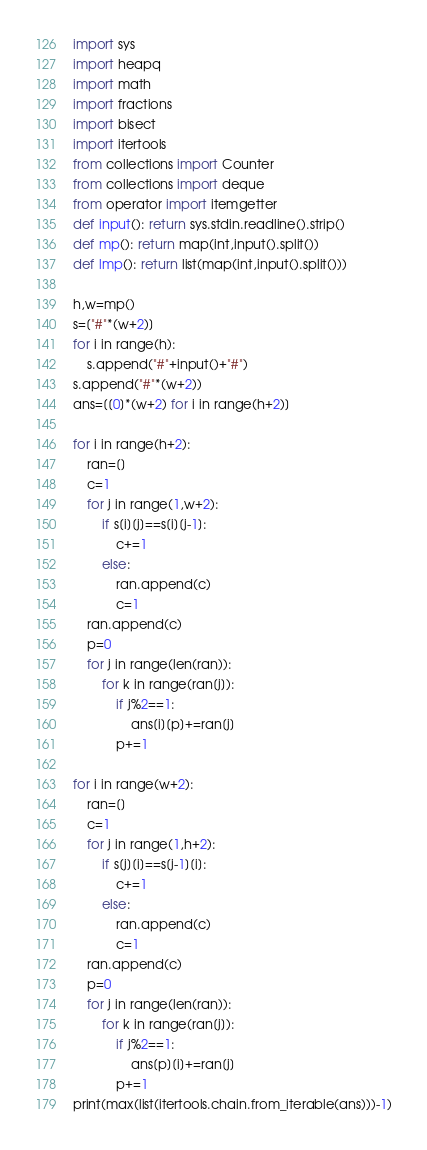Convert code to text. <code><loc_0><loc_0><loc_500><loc_500><_Python_>import sys
import heapq
import math
import fractions
import bisect
import itertools
from collections import Counter
from collections import deque
from operator import itemgetter
def input(): return sys.stdin.readline().strip()
def mp(): return map(int,input().split())
def lmp(): return list(map(int,input().split()))

h,w=mp()
s=["#"*(w+2)]
for i in range(h):
    s.append("#"+input()+"#")
s.append("#"*(w+2))
ans=[[0]*(w+2) for i in range(h+2)]

for i in range(h+2):
    ran=[]
    c=1
    for j in range(1,w+2):
        if s[i][j]==s[i][j-1]:
            c+=1
        else:
            ran.append(c)
            c=1
    ran.append(c)
    p=0
    for j in range(len(ran)):
        for k in range(ran[j]):
            if j%2==1:
                ans[i][p]+=ran[j]
            p+=1

for i in range(w+2):
    ran=[]
    c=1
    for j in range(1,h+2):
        if s[j][i]==s[j-1][i]:
            c+=1
        else:
            ran.append(c)
            c=1
    ran.append(c)
    p=0
    for j in range(len(ran)):
        for k in range(ran[j]):
            if j%2==1:
                ans[p][i]+=ran[j]
            p+=1
print(max(list(itertools.chain.from_iterable(ans)))-1)</code> 